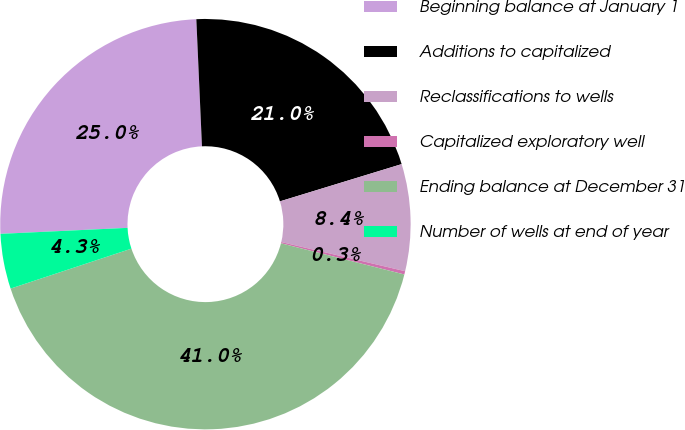<chart> <loc_0><loc_0><loc_500><loc_500><pie_chart><fcel>Beginning balance at January 1<fcel>Additions to capitalized<fcel>Reclassifications to wells<fcel>Capitalized exploratory well<fcel>Ending balance at December 31<fcel>Number of wells at end of year<nl><fcel>25.05%<fcel>20.98%<fcel>8.41%<fcel>0.26%<fcel>40.98%<fcel>4.33%<nl></chart> 